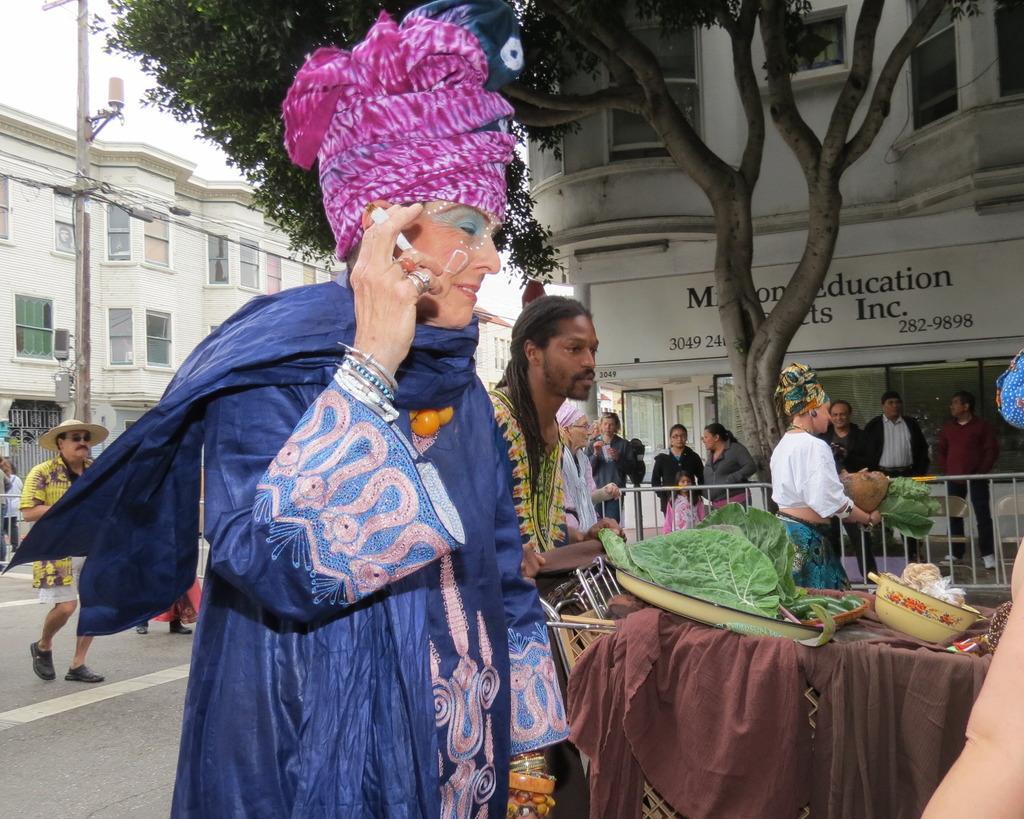Please provide a concise description of this image. Here we can see few persons. There are leaves, plates, bowl, cloth, and a fence. This is a road and there is a pole. In the background we can see buildings, board, tree, and sky. 